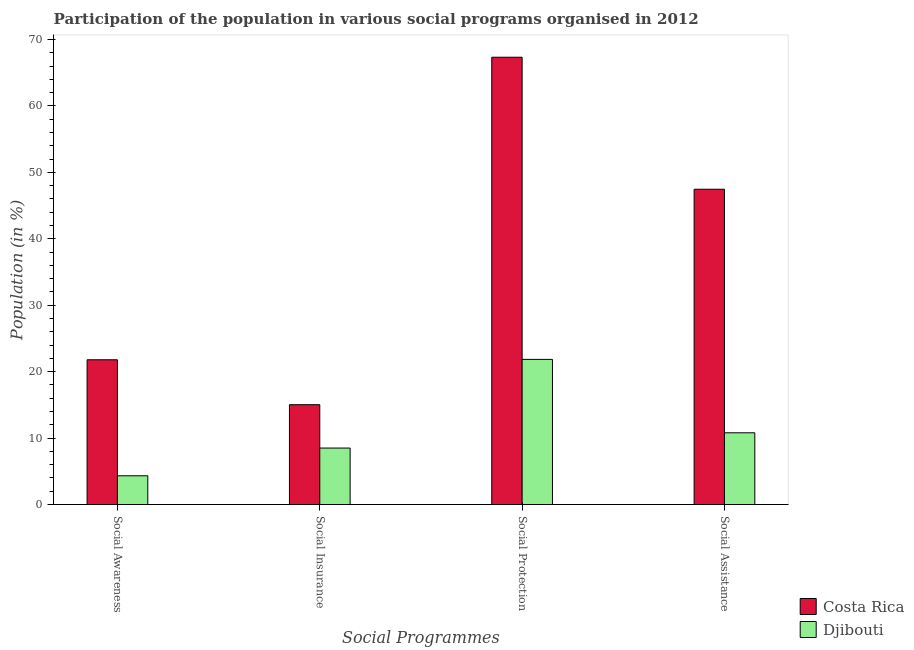How many groups of bars are there?
Make the answer very short. 4. Are the number of bars per tick equal to the number of legend labels?
Your answer should be compact. Yes. What is the label of the 3rd group of bars from the left?
Offer a very short reply. Social Protection. What is the participation of population in social insurance programs in Costa Rica?
Ensure brevity in your answer.  15.03. Across all countries, what is the maximum participation of population in social awareness programs?
Keep it short and to the point. 21.79. Across all countries, what is the minimum participation of population in social insurance programs?
Ensure brevity in your answer.  8.5. In which country was the participation of population in social assistance programs minimum?
Give a very brief answer. Djibouti. What is the total participation of population in social insurance programs in the graph?
Ensure brevity in your answer.  23.53. What is the difference between the participation of population in social insurance programs in Costa Rica and that in Djibouti?
Offer a terse response. 6.53. What is the difference between the participation of population in social awareness programs in Costa Rica and the participation of population in social assistance programs in Djibouti?
Make the answer very short. 10.99. What is the average participation of population in social assistance programs per country?
Provide a succinct answer. 29.13. What is the difference between the participation of population in social awareness programs and participation of population in social protection programs in Djibouti?
Provide a succinct answer. -17.52. In how many countries, is the participation of population in social assistance programs greater than 16 %?
Your answer should be compact. 1. What is the ratio of the participation of population in social insurance programs in Costa Rica to that in Djibouti?
Give a very brief answer. 1.77. Is the difference between the participation of population in social awareness programs in Djibouti and Costa Rica greater than the difference between the participation of population in social assistance programs in Djibouti and Costa Rica?
Your answer should be very brief. Yes. What is the difference between the highest and the second highest participation of population in social insurance programs?
Provide a succinct answer. 6.53. What is the difference between the highest and the lowest participation of population in social assistance programs?
Your answer should be compact. 36.66. Is the sum of the participation of population in social assistance programs in Costa Rica and Djibouti greater than the maximum participation of population in social protection programs across all countries?
Your answer should be very brief. No. What does the 2nd bar from the left in Social Insurance represents?
Give a very brief answer. Djibouti. Is it the case that in every country, the sum of the participation of population in social awareness programs and participation of population in social insurance programs is greater than the participation of population in social protection programs?
Provide a short and direct response. No. How many bars are there?
Provide a short and direct response. 8. What is the difference between two consecutive major ticks on the Y-axis?
Offer a terse response. 10. Are the values on the major ticks of Y-axis written in scientific E-notation?
Give a very brief answer. No. Where does the legend appear in the graph?
Your response must be concise. Bottom right. How many legend labels are there?
Your answer should be compact. 2. How are the legend labels stacked?
Your answer should be very brief. Vertical. What is the title of the graph?
Provide a short and direct response. Participation of the population in various social programs organised in 2012. Does "India" appear as one of the legend labels in the graph?
Provide a short and direct response. No. What is the label or title of the X-axis?
Your answer should be compact. Social Programmes. What is the Population (in %) of Costa Rica in Social Awareness?
Provide a short and direct response. 21.79. What is the Population (in %) in Djibouti in Social Awareness?
Provide a short and direct response. 4.33. What is the Population (in %) of Costa Rica in Social Insurance?
Offer a very short reply. 15.03. What is the Population (in %) of Djibouti in Social Insurance?
Provide a short and direct response. 8.5. What is the Population (in %) in Costa Rica in Social Protection?
Offer a terse response. 67.33. What is the Population (in %) of Djibouti in Social Protection?
Offer a terse response. 21.85. What is the Population (in %) in Costa Rica in Social Assistance?
Ensure brevity in your answer.  47.46. What is the Population (in %) in Djibouti in Social Assistance?
Provide a short and direct response. 10.8. Across all Social Programmes, what is the maximum Population (in %) of Costa Rica?
Give a very brief answer. 67.33. Across all Social Programmes, what is the maximum Population (in %) in Djibouti?
Your answer should be compact. 21.85. Across all Social Programmes, what is the minimum Population (in %) in Costa Rica?
Provide a short and direct response. 15.03. Across all Social Programmes, what is the minimum Population (in %) in Djibouti?
Ensure brevity in your answer.  4.33. What is the total Population (in %) of Costa Rica in the graph?
Keep it short and to the point. 151.61. What is the total Population (in %) of Djibouti in the graph?
Provide a succinct answer. 45.48. What is the difference between the Population (in %) in Costa Rica in Social Awareness and that in Social Insurance?
Provide a short and direct response. 6.76. What is the difference between the Population (in %) of Djibouti in Social Awareness and that in Social Insurance?
Your response must be concise. -4.18. What is the difference between the Population (in %) in Costa Rica in Social Awareness and that in Social Protection?
Your response must be concise. -45.54. What is the difference between the Population (in %) of Djibouti in Social Awareness and that in Social Protection?
Ensure brevity in your answer.  -17.52. What is the difference between the Population (in %) of Costa Rica in Social Awareness and that in Social Assistance?
Offer a very short reply. -25.67. What is the difference between the Population (in %) of Djibouti in Social Awareness and that in Social Assistance?
Your answer should be compact. -6.47. What is the difference between the Population (in %) in Costa Rica in Social Insurance and that in Social Protection?
Offer a terse response. -52.3. What is the difference between the Population (in %) in Djibouti in Social Insurance and that in Social Protection?
Keep it short and to the point. -13.35. What is the difference between the Population (in %) of Costa Rica in Social Insurance and that in Social Assistance?
Provide a short and direct response. -32.43. What is the difference between the Population (in %) in Djibouti in Social Insurance and that in Social Assistance?
Provide a succinct answer. -2.3. What is the difference between the Population (in %) in Costa Rica in Social Protection and that in Social Assistance?
Give a very brief answer. 19.87. What is the difference between the Population (in %) of Djibouti in Social Protection and that in Social Assistance?
Offer a terse response. 11.05. What is the difference between the Population (in %) of Costa Rica in Social Awareness and the Population (in %) of Djibouti in Social Insurance?
Offer a terse response. 13.29. What is the difference between the Population (in %) in Costa Rica in Social Awareness and the Population (in %) in Djibouti in Social Protection?
Your answer should be very brief. -0.06. What is the difference between the Population (in %) in Costa Rica in Social Awareness and the Population (in %) in Djibouti in Social Assistance?
Provide a succinct answer. 10.99. What is the difference between the Population (in %) in Costa Rica in Social Insurance and the Population (in %) in Djibouti in Social Protection?
Your response must be concise. -6.82. What is the difference between the Population (in %) in Costa Rica in Social Insurance and the Population (in %) in Djibouti in Social Assistance?
Give a very brief answer. 4.23. What is the difference between the Population (in %) of Costa Rica in Social Protection and the Population (in %) of Djibouti in Social Assistance?
Keep it short and to the point. 56.53. What is the average Population (in %) in Costa Rica per Social Programmes?
Provide a succinct answer. 37.9. What is the average Population (in %) of Djibouti per Social Programmes?
Keep it short and to the point. 11.37. What is the difference between the Population (in %) of Costa Rica and Population (in %) of Djibouti in Social Awareness?
Ensure brevity in your answer.  17.46. What is the difference between the Population (in %) in Costa Rica and Population (in %) in Djibouti in Social Insurance?
Keep it short and to the point. 6.53. What is the difference between the Population (in %) in Costa Rica and Population (in %) in Djibouti in Social Protection?
Keep it short and to the point. 45.48. What is the difference between the Population (in %) of Costa Rica and Population (in %) of Djibouti in Social Assistance?
Make the answer very short. 36.66. What is the ratio of the Population (in %) in Costa Rica in Social Awareness to that in Social Insurance?
Ensure brevity in your answer.  1.45. What is the ratio of the Population (in %) of Djibouti in Social Awareness to that in Social Insurance?
Provide a succinct answer. 0.51. What is the ratio of the Population (in %) in Costa Rica in Social Awareness to that in Social Protection?
Offer a very short reply. 0.32. What is the ratio of the Population (in %) in Djibouti in Social Awareness to that in Social Protection?
Offer a terse response. 0.2. What is the ratio of the Population (in %) of Costa Rica in Social Awareness to that in Social Assistance?
Give a very brief answer. 0.46. What is the ratio of the Population (in %) of Djibouti in Social Awareness to that in Social Assistance?
Ensure brevity in your answer.  0.4. What is the ratio of the Population (in %) of Costa Rica in Social Insurance to that in Social Protection?
Offer a very short reply. 0.22. What is the ratio of the Population (in %) in Djibouti in Social Insurance to that in Social Protection?
Keep it short and to the point. 0.39. What is the ratio of the Population (in %) in Costa Rica in Social Insurance to that in Social Assistance?
Your response must be concise. 0.32. What is the ratio of the Population (in %) in Djibouti in Social Insurance to that in Social Assistance?
Offer a very short reply. 0.79. What is the ratio of the Population (in %) in Costa Rica in Social Protection to that in Social Assistance?
Offer a terse response. 1.42. What is the ratio of the Population (in %) in Djibouti in Social Protection to that in Social Assistance?
Your answer should be compact. 2.02. What is the difference between the highest and the second highest Population (in %) of Costa Rica?
Provide a short and direct response. 19.87. What is the difference between the highest and the second highest Population (in %) in Djibouti?
Make the answer very short. 11.05. What is the difference between the highest and the lowest Population (in %) in Costa Rica?
Provide a succinct answer. 52.3. What is the difference between the highest and the lowest Population (in %) of Djibouti?
Keep it short and to the point. 17.52. 